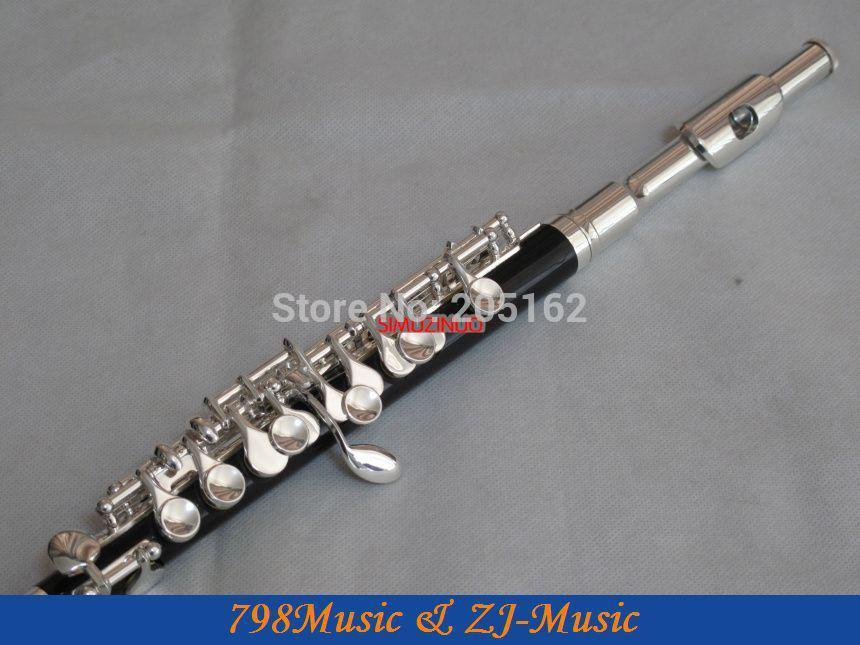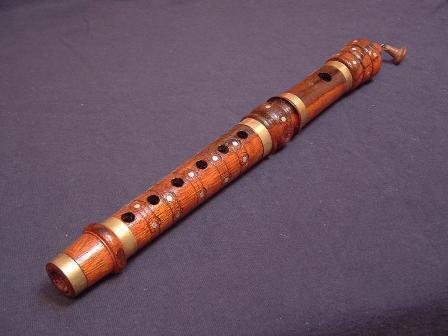The first image is the image on the left, the second image is the image on the right. Considering the images on both sides, is "One of the images shows an instrument with buttons that are pressed to change notes while the other just has finger holes that get covered to changed notes." valid? Answer yes or no. Yes. The first image is the image on the left, the second image is the image on the right. Assess this claim about the two images: "The left image contains only a diagonally displayed flute with metal buttons, and the right image includes only a diagonally displayed flute without metal buttons.". Correct or not? Answer yes or no. Yes. 